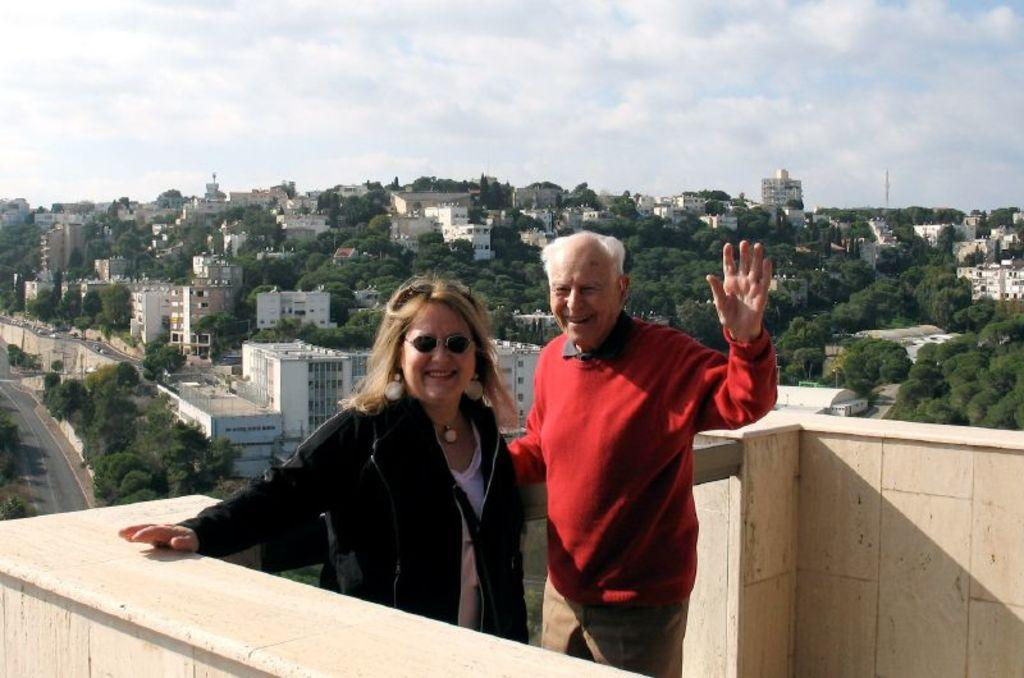How many people are in the image? There are two persons in the image. What are the persons doing in the image? The persons are standing in front of a wall and smiling. What can be seen in the middle of the image? There are houses and trees in the middle of the image. What is visible at the top of the image? The sky is visible at the top of the image. What type of pin can be seen holding the houses together in the image? There is no pin present in the image, and the houses are not held together by any visible means. 